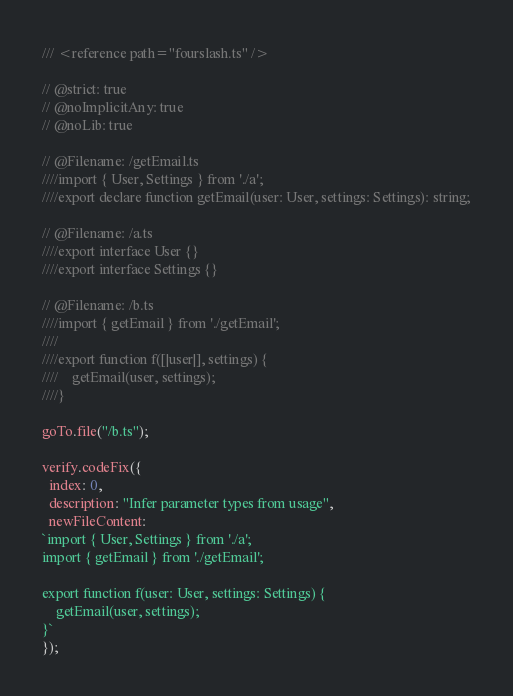<code> <loc_0><loc_0><loc_500><loc_500><_TypeScript_>/// <reference path="fourslash.ts" />

// @strict: true
// @noImplicitAny: true
// @noLib: true

// @Filename: /getEmail.ts
////import { User, Settings } from './a';
////export declare function getEmail(user: User, settings: Settings): string;

// @Filename: /a.ts
////export interface User {}
////export interface Settings {}

// @Filename: /b.ts
////import { getEmail } from './getEmail';
////
////export function f([|user|], settings) {
////    getEmail(user, settings);
////}

goTo.file("/b.ts");

verify.codeFix({
  index: 0,
  description: "Infer parameter types from usage",
  newFileContent:
`import { User, Settings } from './a';
import { getEmail } from './getEmail';

export function f(user: User, settings: Settings) {
    getEmail(user, settings);
}`
});
</code> 